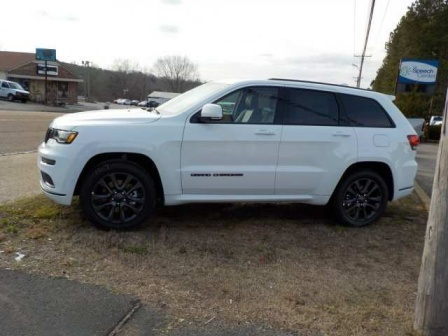Can you create a story about what might be happening in this image? In this quiet suburban setting, a white Jeep Grand Cherokee is parked by the roadside. The car belongs to a nature enthusiast named Alex who stopped here to explore a hidden trail nearby. Alex had read about this trail, known for its stunning views and serene atmosphere. With a backpack ready, Alex planned a peaceful hike, capturing the beauty of the surroundings with a camera. The nearby building is a quaint coffee shop where Alex plans to stop after the hike to enjoy a hot drink and reflect on the day's adventure. 